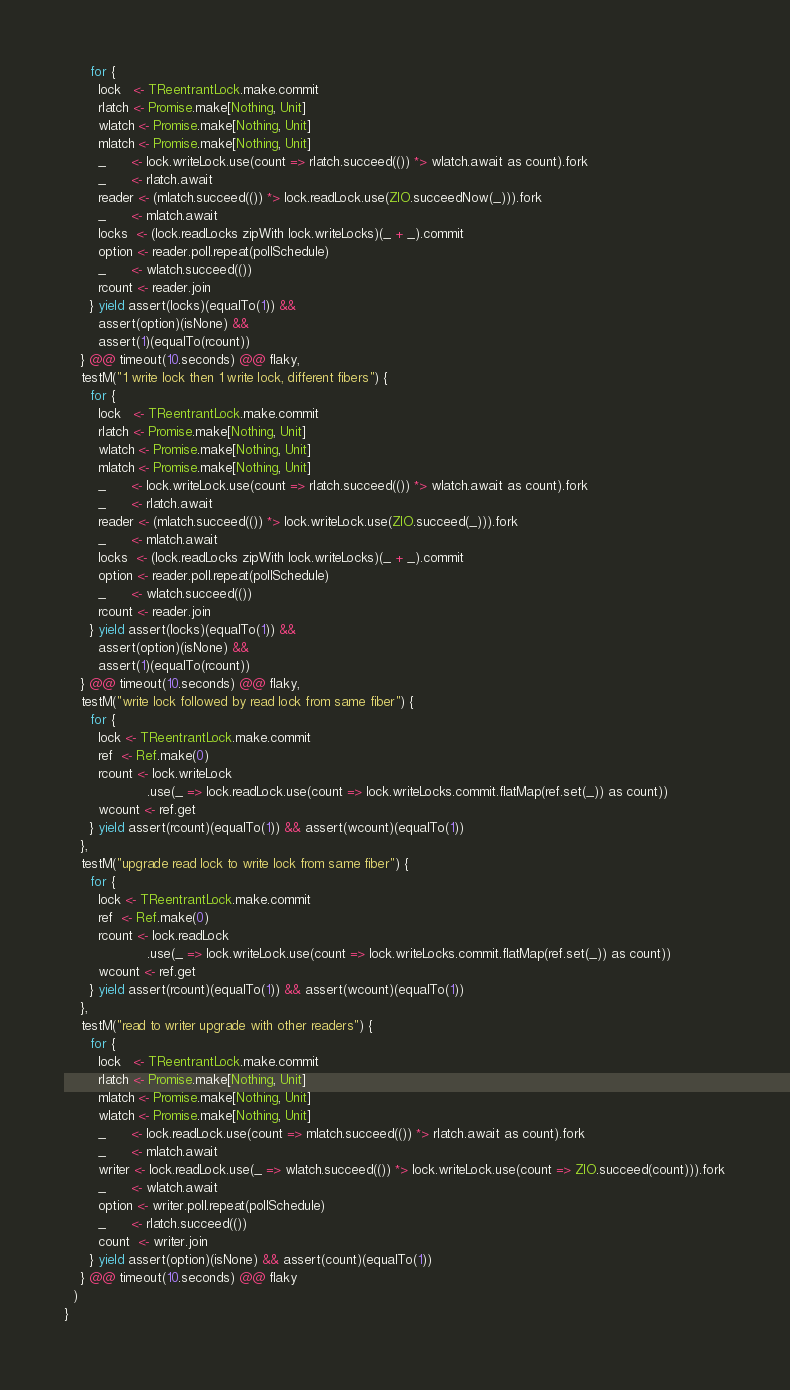Convert code to text. <code><loc_0><loc_0><loc_500><loc_500><_Scala_>      for {
        lock   <- TReentrantLock.make.commit
        rlatch <- Promise.make[Nothing, Unit]
        wlatch <- Promise.make[Nothing, Unit]
        mlatch <- Promise.make[Nothing, Unit]
        _      <- lock.writeLock.use(count => rlatch.succeed(()) *> wlatch.await as count).fork
        _      <- rlatch.await
        reader <- (mlatch.succeed(()) *> lock.readLock.use(ZIO.succeedNow(_))).fork
        _      <- mlatch.await
        locks  <- (lock.readLocks zipWith lock.writeLocks)(_ + _).commit
        option <- reader.poll.repeat(pollSchedule)
        _      <- wlatch.succeed(())
        rcount <- reader.join
      } yield assert(locks)(equalTo(1)) &&
        assert(option)(isNone) &&
        assert(1)(equalTo(rcount))
    } @@ timeout(10.seconds) @@ flaky,
    testM("1 write lock then 1 write lock, different fibers") {
      for {
        lock   <- TReentrantLock.make.commit
        rlatch <- Promise.make[Nothing, Unit]
        wlatch <- Promise.make[Nothing, Unit]
        mlatch <- Promise.make[Nothing, Unit]
        _      <- lock.writeLock.use(count => rlatch.succeed(()) *> wlatch.await as count).fork
        _      <- rlatch.await
        reader <- (mlatch.succeed(()) *> lock.writeLock.use(ZIO.succeed(_))).fork
        _      <- mlatch.await
        locks  <- (lock.readLocks zipWith lock.writeLocks)(_ + _).commit
        option <- reader.poll.repeat(pollSchedule)
        _      <- wlatch.succeed(())
        rcount <- reader.join
      } yield assert(locks)(equalTo(1)) &&
        assert(option)(isNone) &&
        assert(1)(equalTo(rcount))
    } @@ timeout(10.seconds) @@ flaky,
    testM("write lock followed by read lock from same fiber") {
      for {
        lock <- TReentrantLock.make.commit
        ref  <- Ref.make(0)
        rcount <- lock.writeLock
                    .use(_ => lock.readLock.use(count => lock.writeLocks.commit.flatMap(ref.set(_)) as count))
        wcount <- ref.get
      } yield assert(rcount)(equalTo(1)) && assert(wcount)(equalTo(1))
    },
    testM("upgrade read lock to write lock from same fiber") {
      for {
        lock <- TReentrantLock.make.commit
        ref  <- Ref.make(0)
        rcount <- lock.readLock
                    .use(_ => lock.writeLock.use(count => lock.writeLocks.commit.flatMap(ref.set(_)) as count))
        wcount <- ref.get
      } yield assert(rcount)(equalTo(1)) && assert(wcount)(equalTo(1))
    },
    testM("read to writer upgrade with other readers") {
      for {
        lock   <- TReentrantLock.make.commit
        rlatch <- Promise.make[Nothing, Unit]
        mlatch <- Promise.make[Nothing, Unit]
        wlatch <- Promise.make[Nothing, Unit]
        _      <- lock.readLock.use(count => mlatch.succeed(()) *> rlatch.await as count).fork
        _      <- mlatch.await
        writer <- lock.readLock.use(_ => wlatch.succeed(()) *> lock.writeLock.use(count => ZIO.succeed(count))).fork
        _      <- wlatch.await
        option <- writer.poll.repeat(pollSchedule)
        _      <- rlatch.succeed(())
        count  <- writer.join
      } yield assert(option)(isNone) && assert(count)(equalTo(1))
    } @@ timeout(10.seconds) @@ flaky
  )
}
</code> 